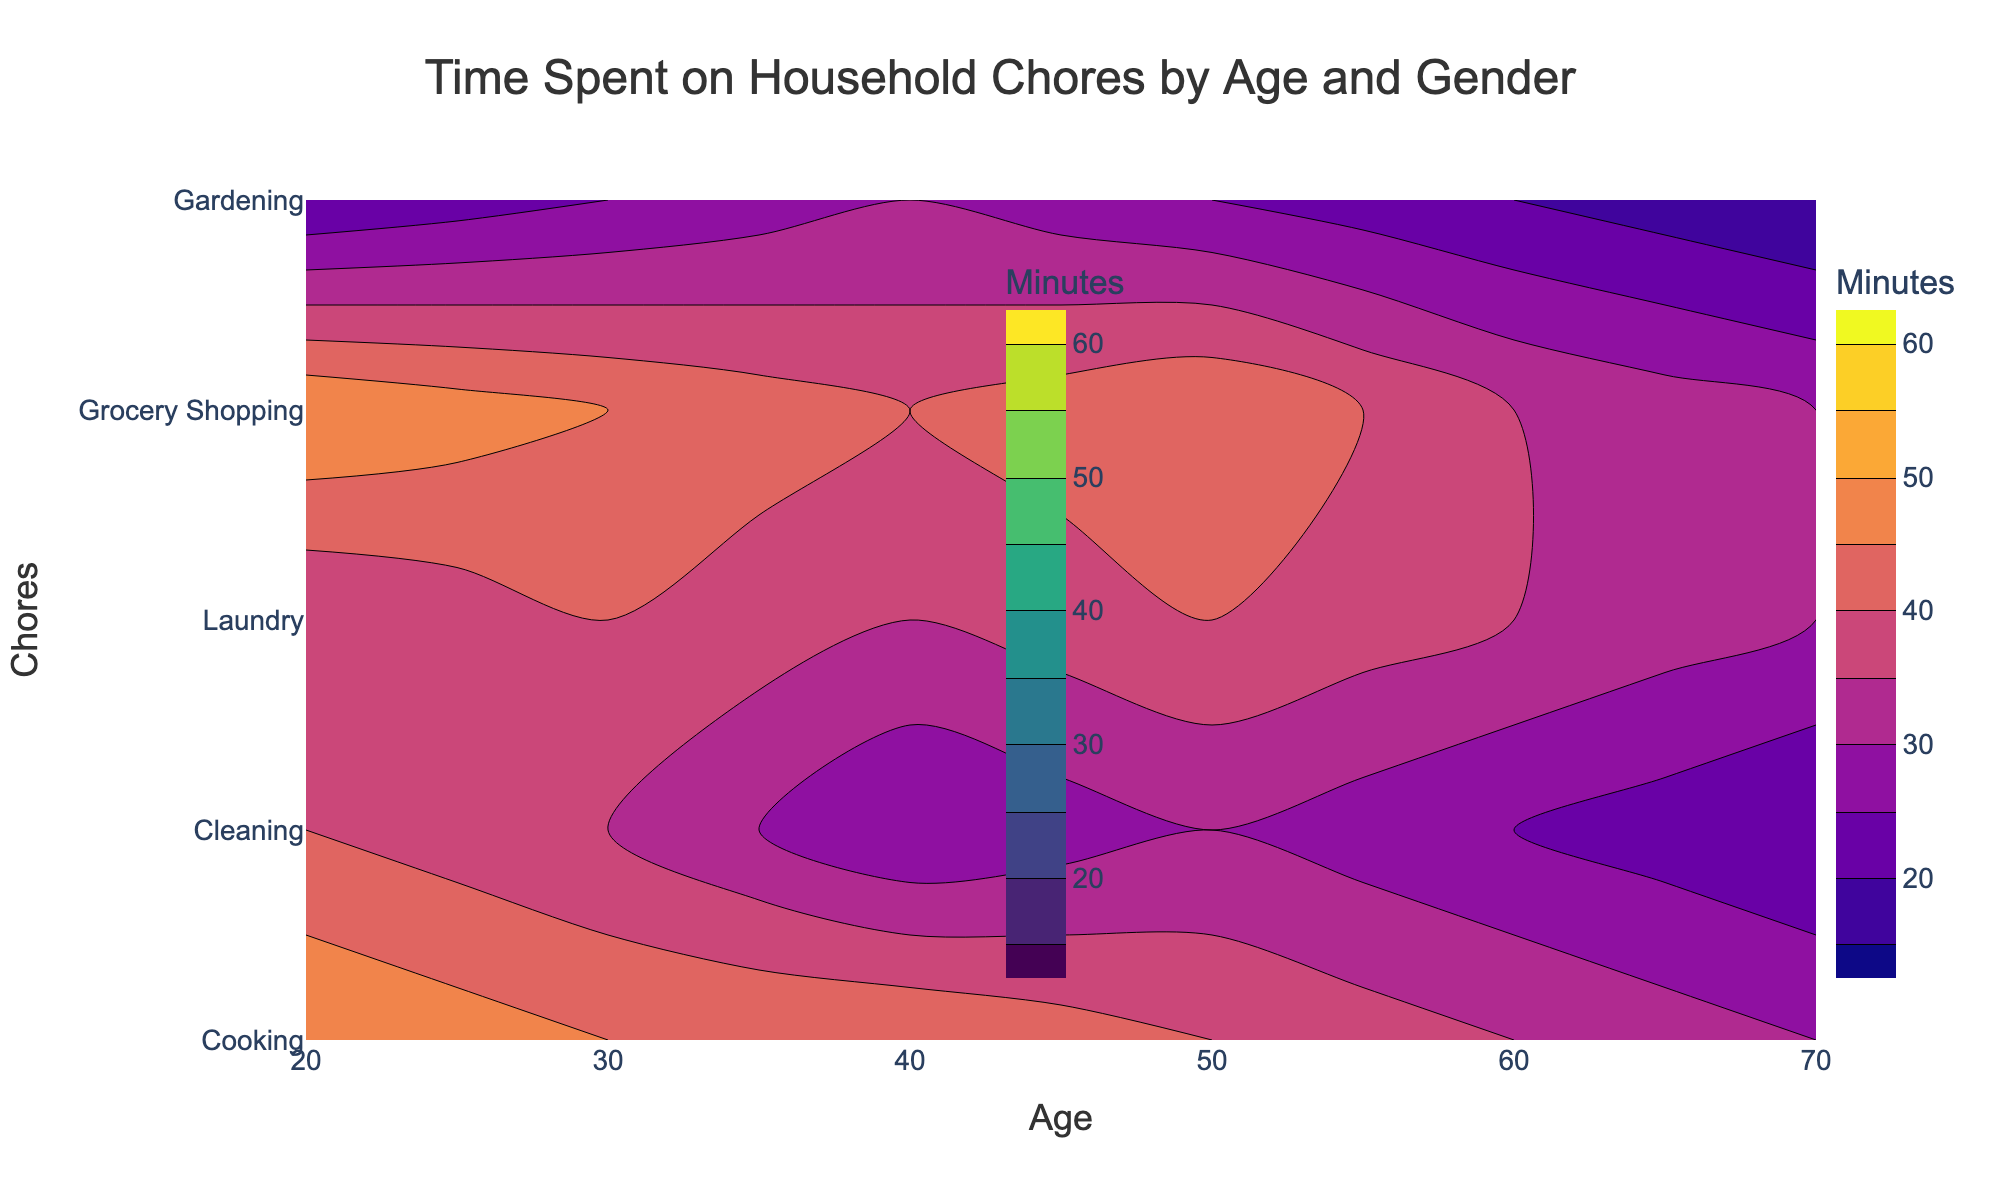What is the title of the figure? The title of the figure is usually the largest text at the top, describing the figure's content directly. In this case, it is "Time Spent on Household Chores by Age and Gender".
Answer: Time Spent on Household Chores by Age and Gender What chores are being analyzed in the figure? Look at the y-axis labels to identify the chores being analyzed. They are listed as: Cooking, Cleaning, Laundry, Grocery Shopping, and Gardening.
Answer: Cooking, Cleaning, Laundry, Grocery Shopping, Gardening How does the time spent on cooking by males change with age? To understand this, trace the Cooking contour for males across the age axis from 20 to 70. The time spent on cooking by males decreases as age increases from 60 minutes at age 20 to 35 minutes at age 70.
Answer: Decreases At what age do females spend the maximum time gardening? Observe the contours for Gardening in the female plot. The maximum contour (30 minutes) appears at age 40.
Answer: 40 Who spends more time on grocery shopping at age 50, males or females? Compare the contours for Grocery Shopping at age 50. Females spend 45 minutes, while males spend 35 minutes.
Answer: Females Which gender spends more time on laundry at age 30? Compare the contours for Laundry at age 30. Females spend 40 minutes, while males spend 30 minutes.
Answer: Females How does the time spent on cleaning by females change from ages 20 to 60? Trace the Cleaning contour for females across the age axis. Time spent on cleaning decreases from 40 minutes at age 20 to 25 minutes at age 60.
Answer: Decreases What is the average time spent on cooking by males across all age groups? To find the average, add the values of the Cooking contour for males across all age groups (60, 50, 55, 45, 40, 35) and divide by the number of points (6). (60+50+55+45+40+35) / 6 = 47.5
Answer: 47.5 minutes Comparing males and females, who spends less time on gardening at age 70? Check the contours for Gardening at age 70. Males spend 10 minutes, and females spend 15 minutes. Males spend less time.
Answer: Males Which chore shows the least variation in time spent by both genders across different ages? Observe the contour patterns for all chores. Gardening shows the least variation, with a range between 10 to 30 minutes for both genders.
Answer: Gardening 